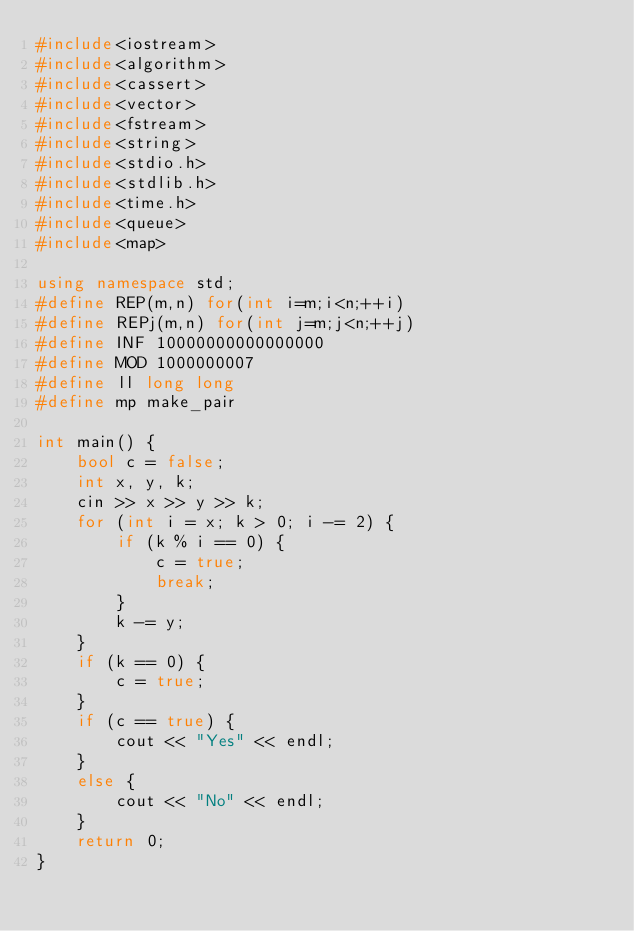Convert code to text. <code><loc_0><loc_0><loc_500><loc_500><_C++_>#include<iostream>
#include<algorithm>
#include<cassert>
#include<vector>
#include<fstream>
#include<string>
#include<stdio.h>
#include<stdlib.h>
#include<time.h>
#include<queue>
#include<map>

using namespace std;
#define REP(m,n) for(int i=m;i<n;++i)
#define REPj(m,n) for(int j=m;j<n;++j)
#define INF 10000000000000000
#define MOD 1000000007
#define ll long long
#define mp make_pair

int main() {
	bool c = false;
	int x, y, k;
	cin >> x >> y >> k;
	for (int i = x; k > 0; i -= 2) {
		if (k % i == 0) {
			c = true;
			break;
		}
		k -= y;
	}
	if (k == 0) {
		c = true;
	}
	if (c == true) {
		cout << "Yes" << endl;
	}
	else {
		cout << "No" << endl;
	}
	return 0;
}</code> 